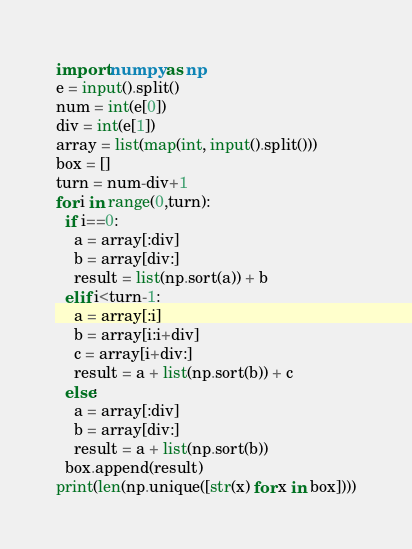<code> <loc_0><loc_0><loc_500><loc_500><_Python_>import numpy as np
e = input().split()
num = int(e[0])
div = int(e[1])
array = list(map(int, input().split()))
box = []
turn = num-div+1
for i in range(0,turn):
  if i==0:
    a = array[:div]
    b = array[div:]
    result = list(np.sort(a)) + b
  elif i<turn-1:
    a = array[:i]
    b = array[i:i+div]
    c = array[i+div:]
    result = a + list(np.sort(b)) + c
  else:
    a = array[:div]
    b = array[div:]
    result = a + list(np.sort(b))
  box.append(result)
print(len(np.unique([str(x) for x in box])))</code> 